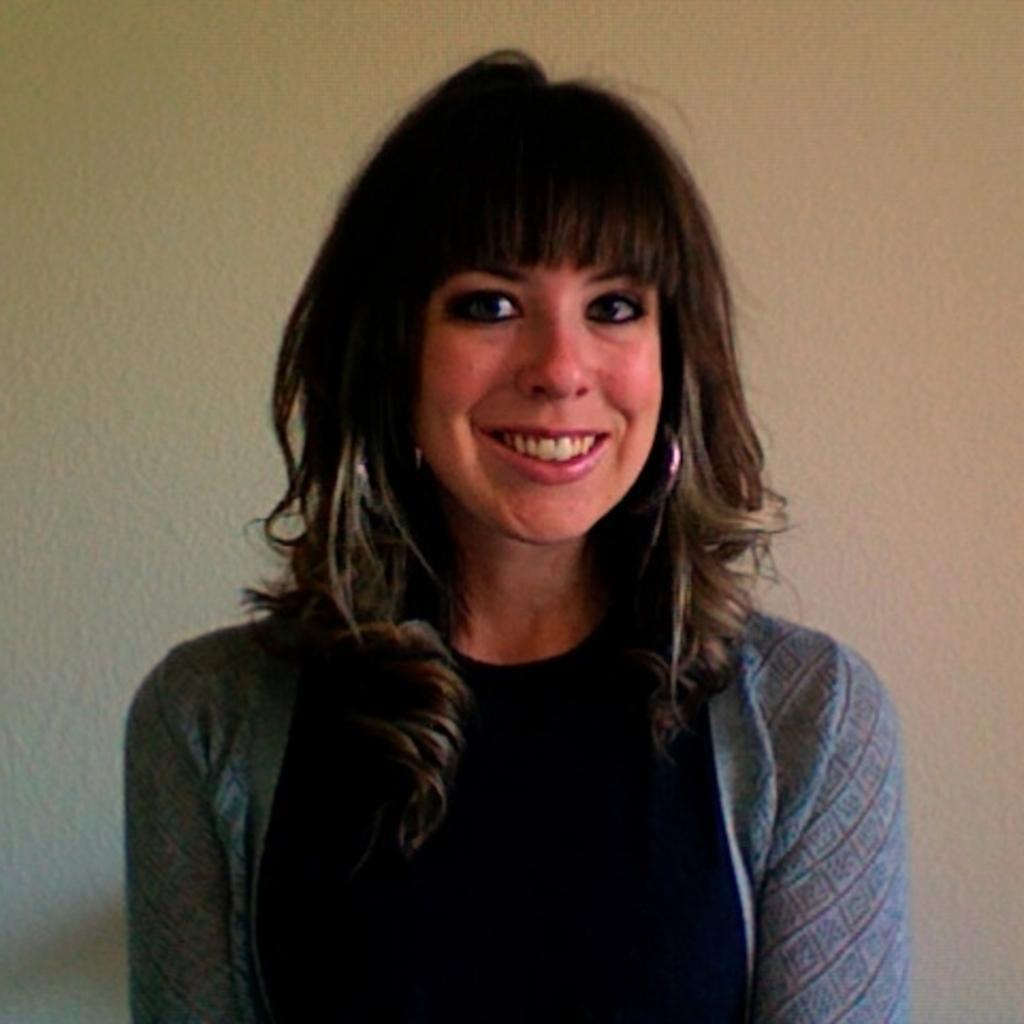Could you give a brief overview of what you see in this image? In the center of the image we can see a lady is standing and wearing dress and smiling. In the background of the image we can see the wall. 